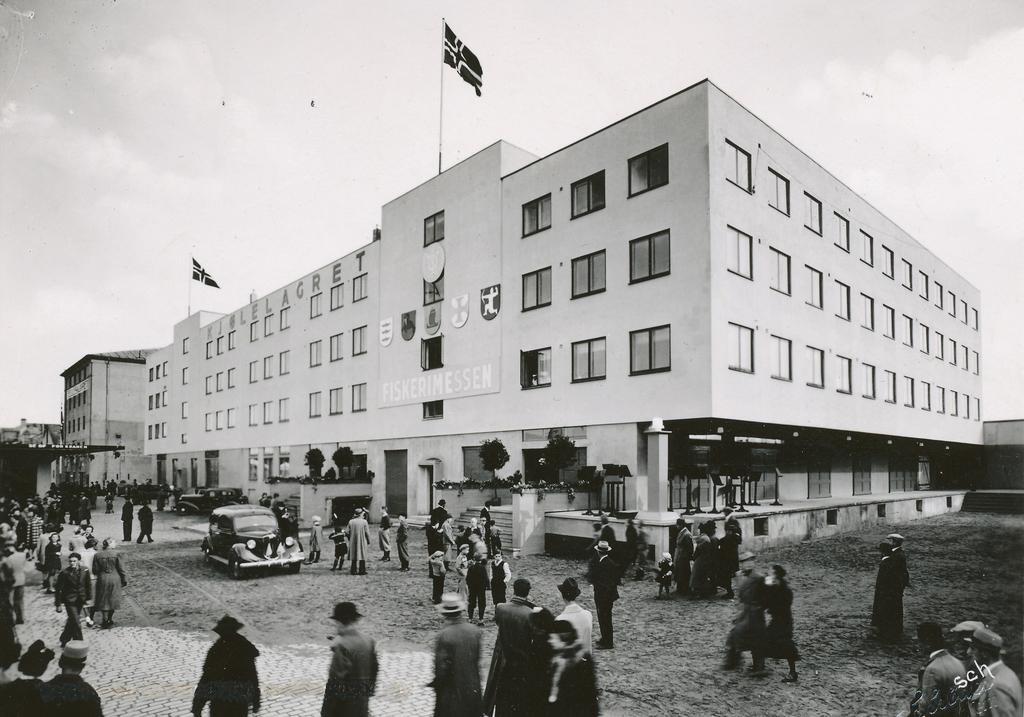In one or two sentences, can you explain what this image depicts? In this image we can see there are people standing on the ground and there are vehicles. And there are buildings, trees, stands and flags attached to the building. And there is the sky in the background. 